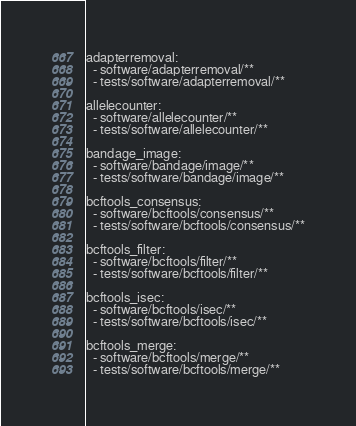<code> <loc_0><loc_0><loc_500><loc_500><_YAML_>adapterremoval:
  - software/adapterremoval/**
  - tests/software/adapterremoval/**

allelecounter:
  - software/allelecounter/**
  - tests/software/allelecounter/**

bandage_image:
  - software/bandage/image/**
  - tests/software/bandage/image/**

bcftools_consensus:
  - software/bcftools/consensus/**
  - tests/software/bcftools/consensus/**

bcftools_filter:
  - software/bcftools/filter/**
  - tests/software/bcftools/filter/**

bcftools_isec:
  - software/bcftools/isec/**
  - tests/software/bcftools/isec/**

bcftools_merge:
  - software/bcftools/merge/**
  - tests/software/bcftools/merge/**
</code> 